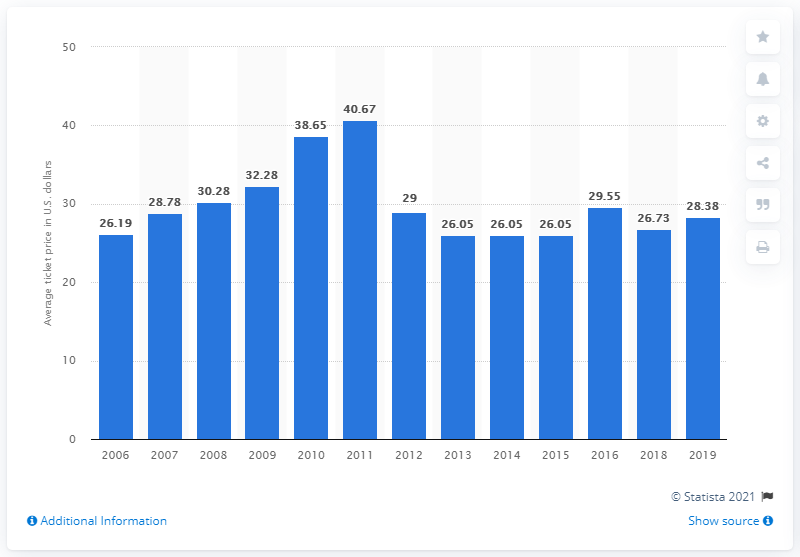Give some essential details in this illustration. In 2019, the average ticket price for White Sox games was 28.38 dollars. 